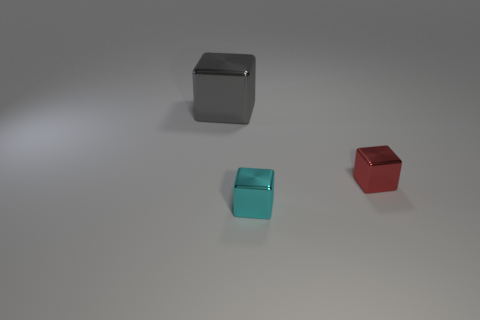Add 3 small red metal objects. How many objects exist? 6 Add 1 cyan metal cubes. How many cyan metal cubes exist? 2 Subtract 0 brown spheres. How many objects are left? 3 Subtract all red things. Subtract all large cubes. How many objects are left? 1 Add 1 small cyan shiny blocks. How many small cyan shiny blocks are left? 2 